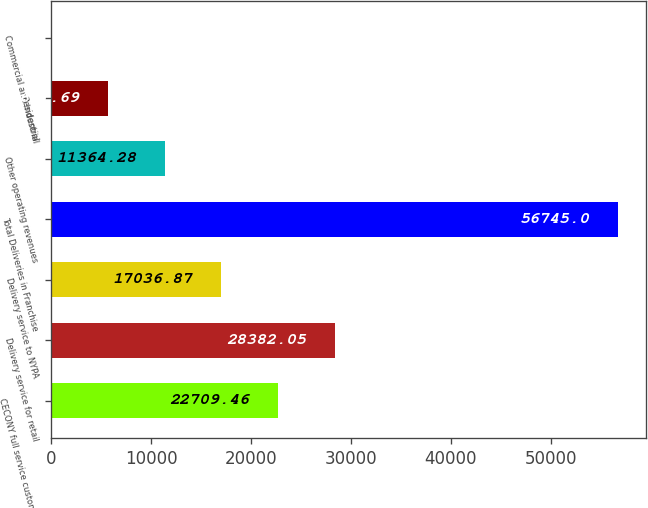Convert chart to OTSL. <chart><loc_0><loc_0><loc_500><loc_500><bar_chart><fcel>CECONY full service customers<fcel>Delivery service for retail<fcel>Delivery service to NYPA<fcel>Total Deliveries in Franchise<fcel>Other operating revenues<fcel>Residential<fcel>Commercial and Industrial<nl><fcel>22709.5<fcel>28382<fcel>17036.9<fcel>56745<fcel>11364.3<fcel>5691.69<fcel>19.1<nl></chart> 